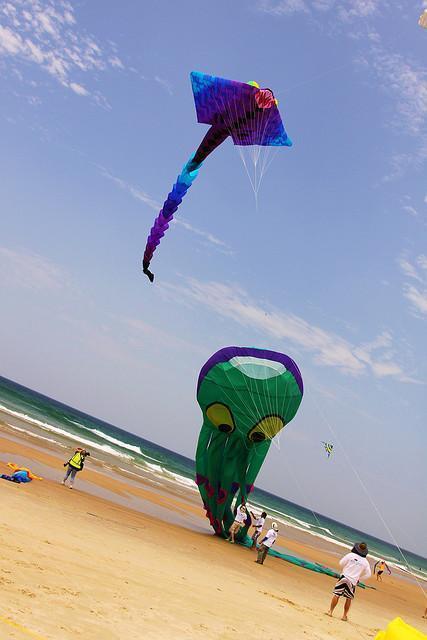How many kites in the picture?
Give a very brief answer. 3. How many kites are visible?
Give a very brief answer. 2. How many slices of pizza are missing?
Give a very brief answer. 0. 